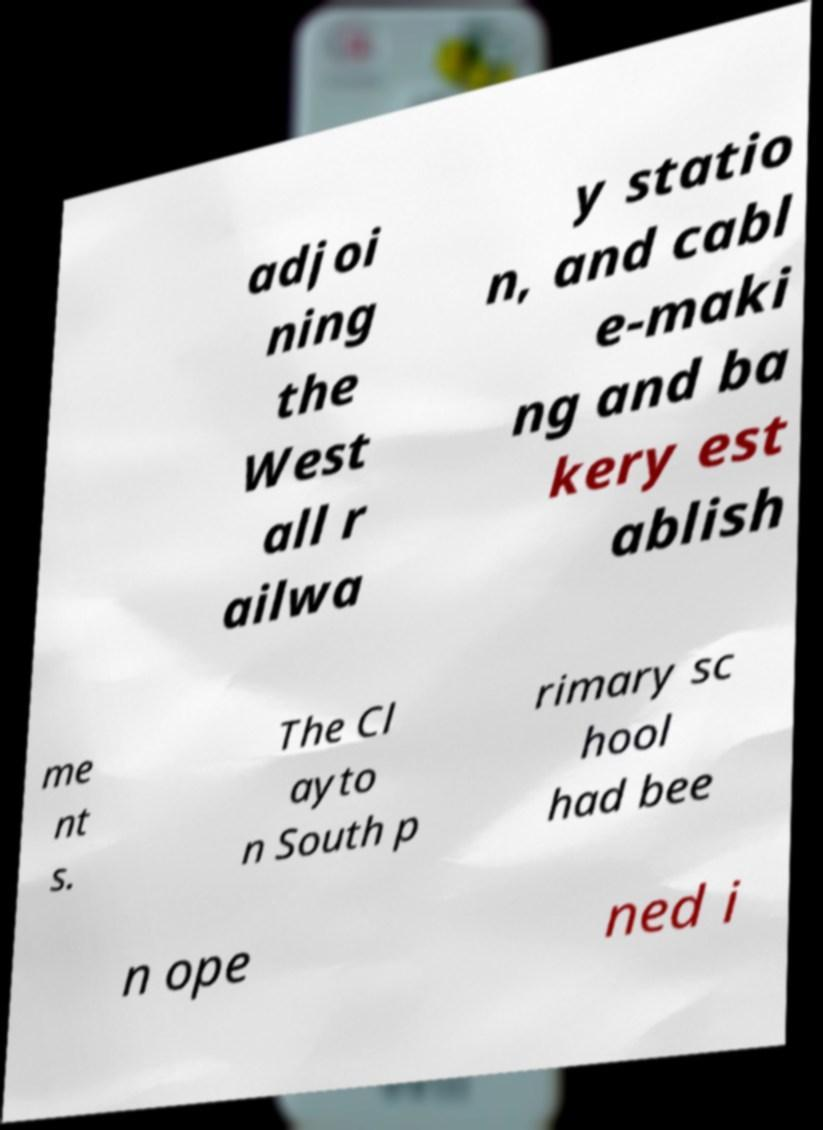There's text embedded in this image that I need extracted. Can you transcribe it verbatim? adjoi ning the West all r ailwa y statio n, and cabl e-maki ng and ba kery est ablish me nt s. The Cl ayto n South p rimary sc hool had bee n ope ned i 